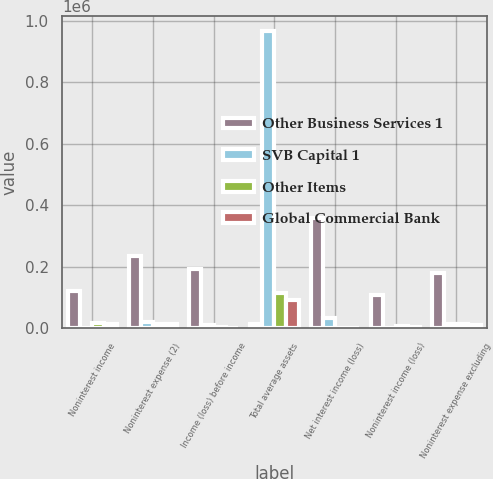Convert chart to OTSL. <chart><loc_0><loc_0><loc_500><loc_500><stacked_bar_chart><ecel><fcel>Noninterest income<fcel>Noninterest expense (2)<fcel>Income (loss) before income<fcel>Total average assets<fcel>Net interest income (loss)<fcel>Noninterest income (loss)<fcel>Noninterest expense excluding<nl><fcel>Other Business Services 1<fcel>121980<fcel>235295<fcel>194258<fcel>15063<fcel>360391<fcel>108307<fcel>181814<nl><fcel>SVB Capital 1<fcel>1507<fcel>20345<fcel>9875<fcel>966900<fcel>34689<fcel>1356<fcel>14432<nl><fcel>Other Items<fcel>18778<fcel>15063<fcel>3715<fcel>116690<fcel>16<fcel>6521<fcel>14487<nl><fcel>Global Commercial Bank<fcel>14798<fcel>15113<fcel>69<fcel>93471<fcel>241<fcel>6078<fcel>11979<nl></chart> 